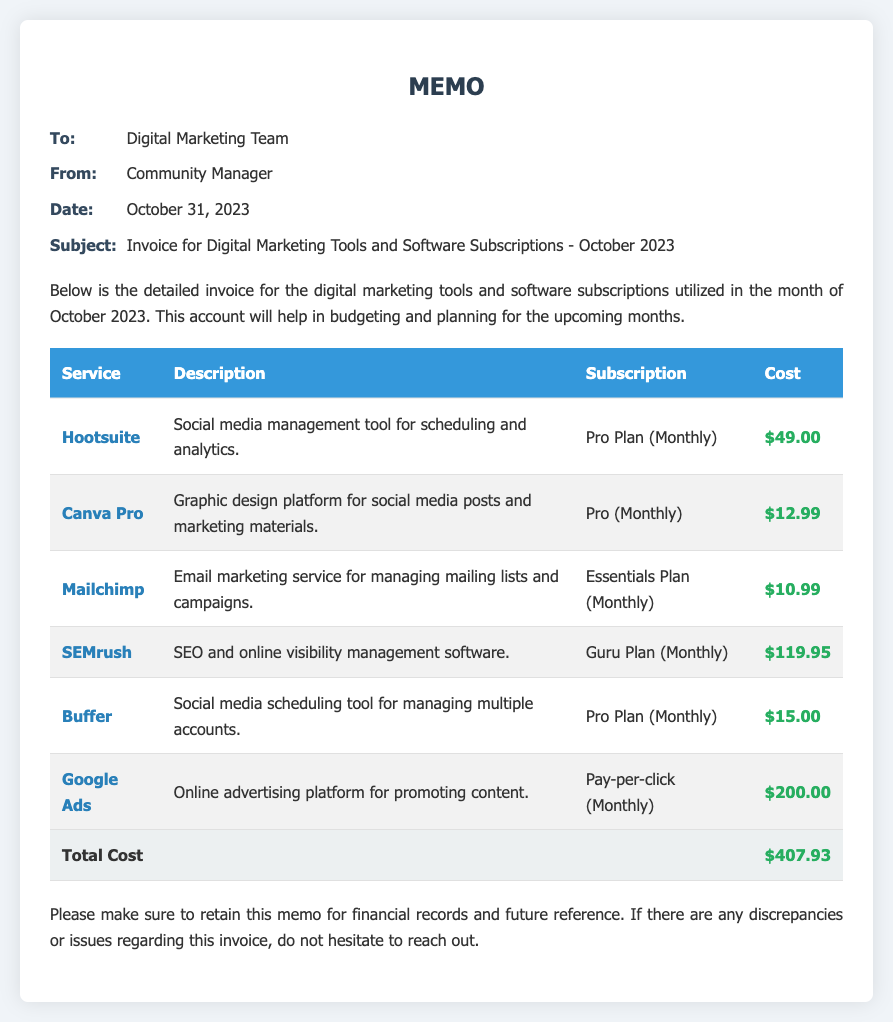what is the date of the memo? The date is specified in the memo details section, which states October 31, 2023.
Answer: October 31, 2023 who is the memo addressed to? The memo is addressed to the Digital Marketing Team.
Answer: Digital Marketing Team what is the total cost listed in the invoice? The total cost is provided in the last row of the table, indicating $407.93.
Answer: $407.93 which service has the highest cost? By examining the cost of each service in the table, Google Ads is the most expensive at $200.00.
Answer: Google Ads how many tools are included in this invoice? Counting the number of services in the table reveals there are six tools listed.
Answer: 6 what is the subscription plan for Hootsuite? The subscription plan for Hootsuite is mentioned as Pro Plan (Monthly).
Answer: Pro Plan (Monthly) what type of document is this? The document is a memo detailing the invoice for digital marketing tools and software subscriptions.
Answer: Memo which service is used for graphic design? The service identified for graphic design in the memo is Canva Pro.
Answer: Canva Pro what is the description of Mailchimp? The description provided for Mailchimp states it is an email marketing service for managing mailing lists and campaigns.
Answer: Email marketing service for managing mailing lists and campaigns 